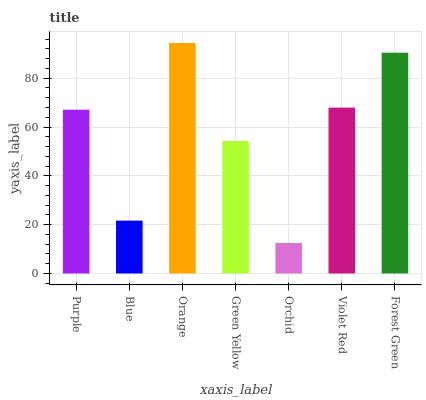Is Blue the minimum?
Answer yes or no. No. Is Blue the maximum?
Answer yes or no. No. Is Purple greater than Blue?
Answer yes or no. Yes. Is Blue less than Purple?
Answer yes or no. Yes. Is Blue greater than Purple?
Answer yes or no. No. Is Purple less than Blue?
Answer yes or no. No. Is Purple the high median?
Answer yes or no. Yes. Is Purple the low median?
Answer yes or no. Yes. Is Blue the high median?
Answer yes or no. No. Is Green Yellow the low median?
Answer yes or no. No. 